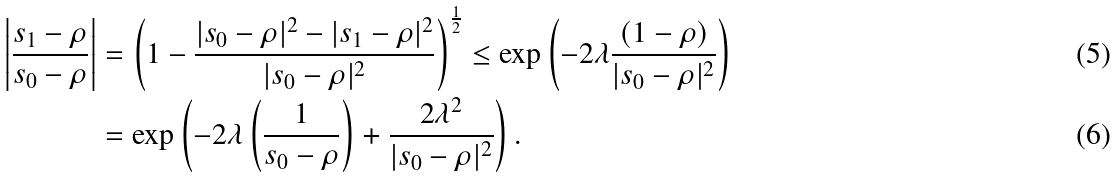<formula> <loc_0><loc_0><loc_500><loc_500>\left | \frac { s _ { 1 } - \rho } { s _ { 0 } - \rho } \right | & = \left ( 1 - \frac { | s _ { 0 } - \rho | ^ { 2 } - | s _ { 1 } - \rho | ^ { 2 } } { | s _ { 0 } - \rho | ^ { 2 } } \right ) ^ { \frac { 1 } { 2 } } \leq \exp \left ( - 2 \lambda \frac { ( 1 - \rho ) } { | s _ { 0 } - \rho | ^ { 2 } } \right ) \\ & = \exp \left ( - 2 \lambda \left ( \frac { 1 } { s _ { 0 } - \rho } \right ) + \frac { 2 \lambda ^ { 2 } } { | s _ { 0 } - \rho | ^ { 2 } } \right ) .</formula> 